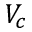Convert formula to latex. <formula><loc_0><loc_0><loc_500><loc_500>V _ { c }</formula> 